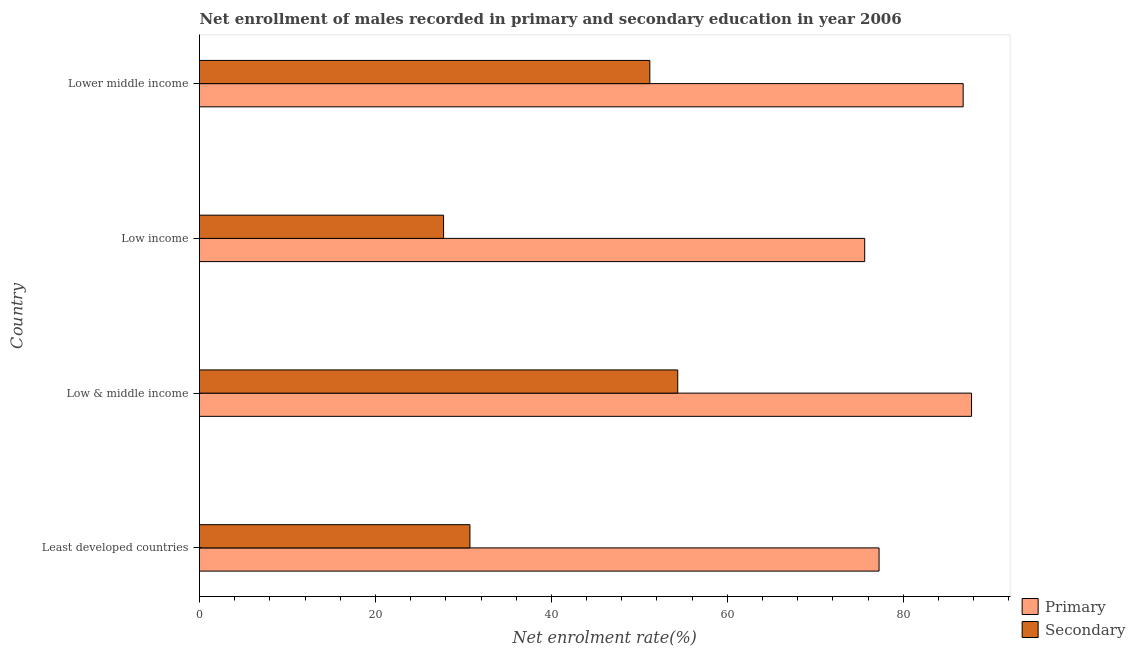How many different coloured bars are there?
Give a very brief answer. 2. How many groups of bars are there?
Offer a terse response. 4. Are the number of bars per tick equal to the number of legend labels?
Keep it short and to the point. Yes. What is the label of the 2nd group of bars from the top?
Offer a very short reply. Low income. What is the enrollment rate in primary education in Low income?
Your response must be concise. 75.61. Across all countries, what is the maximum enrollment rate in secondary education?
Give a very brief answer. 54.36. Across all countries, what is the minimum enrollment rate in primary education?
Your answer should be compact. 75.61. In which country was the enrollment rate in secondary education minimum?
Offer a terse response. Low income. What is the total enrollment rate in secondary education in the graph?
Make the answer very short. 164.04. What is the difference between the enrollment rate in primary education in Least developed countries and that in Lower middle income?
Your answer should be compact. -9.56. What is the difference between the enrollment rate in primary education in Low & middle income and the enrollment rate in secondary education in Lower middle income?
Your answer should be very brief. 36.57. What is the average enrollment rate in secondary education per country?
Offer a very short reply. 41.01. What is the difference between the enrollment rate in primary education and enrollment rate in secondary education in Lower middle income?
Provide a short and direct response. 35.62. In how many countries, is the enrollment rate in secondary education greater than 56 %?
Give a very brief answer. 0. What is the ratio of the enrollment rate in secondary education in Low & middle income to that in Lower middle income?
Your response must be concise. 1.06. What is the difference between the highest and the lowest enrollment rate in primary education?
Offer a very short reply. 12.14. In how many countries, is the enrollment rate in secondary education greater than the average enrollment rate in secondary education taken over all countries?
Your answer should be compact. 2. Is the sum of the enrollment rate in primary education in Low & middle income and Low income greater than the maximum enrollment rate in secondary education across all countries?
Keep it short and to the point. Yes. What does the 1st bar from the top in Least developed countries represents?
Your response must be concise. Secondary. What does the 2nd bar from the bottom in Lower middle income represents?
Make the answer very short. Secondary. What is the difference between two consecutive major ticks on the X-axis?
Provide a short and direct response. 20. Are the values on the major ticks of X-axis written in scientific E-notation?
Offer a terse response. No. Does the graph contain any zero values?
Keep it short and to the point. No. Does the graph contain grids?
Ensure brevity in your answer.  No. Where does the legend appear in the graph?
Your response must be concise. Bottom right. How many legend labels are there?
Your answer should be compact. 2. What is the title of the graph?
Keep it short and to the point. Net enrollment of males recorded in primary and secondary education in year 2006. What is the label or title of the X-axis?
Keep it short and to the point. Net enrolment rate(%). What is the Net enrolment rate(%) in Primary in Least developed countries?
Ensure brevity in your answer.  77.25. What is the Net enrolment rate(%) of Secondary in Least developed countries?
Offer a very short reply. 30.74. What is the Net enrolment rate(%) of Primary in Low & middle income?
Provide a short and direct response. 87.76. What is the Net enrolment rate(%) of Secondary in Low & middle income?
Provide a succinct answer. 54.36. What is the Net enrolment rate(%) of Primary in Low income?
Your answer should be very brief. 75.61. What is the Net enrolment rate(%) in Secondary in Low income?
Ensure brevity in your answer.  27.75. What is the Net enrolment rate(%) in Primary in Lower middle income?
Provide a short and direct response. 86.81. What is the Net enrolment rate(%) of Secondary in Lower middle income?
Give a very brief answer. 51.19. Across all countries, what is the maximum Net enrolment rate(%) of Primary?
Your answer should be very brief. 87.76. Across all countries, what is the maximum Net enrolment rate(%) of Secondary?
Give a very brief answer. 54.36. Across all countries, what is the minimum Net enrolment rate(%) in Primary?
Give a very brief answer. 75.61. Across all countries, what is the minimum Net enrolment rate(%) in Secondary?
Ensure brevity in your answer.  27.75. What is the total Net enrolment rate(%) of Primary in the graph?
Keep it short and to the point. 327.43. What is the total Net enrolment rate(%) in Secondary in the graph?
Ensure brevity in your answer.  164.04. What is the difference between the Net enrolment rate(%) in Primary in Least developed countries and that in Low & middle income?
Keep it short and to the point. -10.51. What is the difference between the Net enrolment rate(%) of Secondary in Least developed countries and that in Low & middle income?
Keep it short and to the point. -23.62. What is the difference between the Net enrolment rate(%) of Primary in Least developed countries and that in Low income?
Give a very brief answer. 1.63. What is the difference between the Net enrolment rate(%) of Secondary in Least developed countries and that in Low income?
Keep it short and to the point. 3. What is the difference between the Net enrolment rate(%) in Primary in Least developed countries and that in Lower middle income?
Provide a short and direct response. -9.56. What is the difference between the Net enrolment rate(%) of Secondary in Least developed countries and that in Lower middle income?
Ensure brevity in your answer.  -20.45. What is the difference between the Net enrolment rate(%) of Primary in Low & middle income and that in Low income?
Give a very brief answer. 12.14. What is the difference between the Net enrolment rate(%) in Secondary in Low & middle income and that in Low income?
Offer a very short reply. 26.62. What is the difference between the Net enrolment rate(%) in Primary in Low & middle income and that in Lower middle income?
Your answer should be very brief. 0.95. What is the difference between the Net enrolment rate(%) in Secondary in Low & middle income and that in Lower middle income?
Ensure brevity in your answer.  3.17. What is the difference between the Net enrolment rate(%) of Primary in Low income and that in Lower middle income?
Provide a succinct answer. -11.19. What is the difference between the Net enrolment rate(%) in Secondary in Low income and that in Lower middle income?
Your answer should be compact. -23.44. What is the difference between the Net enrolment rate(%) of Primary in Least developed countries and the Net enrolment rate(%) of Secondary in Low & middle income?
Offer a terse response. 22.88. What is the difference between the Net enrolment rate(%) in Primary in Least developed countries and the Net enrolment rate(%) in Secondary in Low income?
Provide a succinct answer. 49.5. What is the difference between the Net enrolment rate(%) in Primary in Least developed countries and the Net enrolment rate(%) in Secondary in Lower middle income?
Your response must be concise. 26.06. What is the difference between the Net enrolment rate(%) of Primary in Low & middle income and the Net enrolment rate(%) of Secondary in Low income?
Give a very brief answer. 60.01. What is the difference between the Net enrolment rate(%) in Primary in Low & middle income and the Net enrolment rate(%) in Secondary in Lower middle income?
Ensure brevity in your answer.  36.57. What is the difference between the Net enrolment rate(%) in Primary in Low income and the Net enrolment rate(%) in Secondary in Lower middle income?
Your answer should be compact. 24.42. What is the average Net enrolment rate(%) of Primary per country?
Your answer should be very brief. 81.86. What is the average Net enrolment rate(%) of Secondary per country?
Give a very brief answer. 41.01. What is the difference between the Net enrolment rate(%) in Primary and Net enrolment rate(%) in Secondary in Least developed countries?
Keep it short and to the point. 46.51. What is the difference between the Net enrolment rate(%) of Primary and Net enrolment rate(%) of Secondary in Low & middle income?
Provide a succinct answer. 33.39. What is the difference between the Net enrolment rate(%) in Primary and Net enrolment rate(%) in Secondary in Low income?
Your answer should be compact. 47.87. What is the difference between the Net enrolment rate(%) in Primary and Net enrolment rate(%) in Secondary in Lower middle income?
Provide a succinct answer. 35.62. What is the ratio of the Net enrolment rate(%) of Primary in Least developed countries to that in Low & middle income?
Offer a very short reply. 0.88. What is the ratio of the Net enrolment rate(%) of Secondary in Least developed countries to that in Low & middle income?
Your answer should be very brief. 0.57. What is the ratio of the Net enrolment rate(%) in Primary in Least developed countries to that in Low income?
Provide a short and direct response. 1.02. What is the ratio of the Net enrolment rate(%) in Secondary in Least developed countries to that in Low income?
Your answer should be compact. 1.11. What is the ratio of the Net enrolment rate(%) in Primary in Least developed countries to that in Lower middle income?
Keep it short and to the point. 0.89. What is the ratio of the Net enrolment rate(%) in Secondary in Least developed countries to that in Lower middle income?
Provide a short and direct response. 0.6. What is the ratio of the Net enrolment rate(%) of Primary in Low & middle income to that in Low income?
Your answer should be compact. 1.16. What is the ratio of the Net enrolment rate(%) of Secondary in Low & middle income to that in Low income?
Offer a terse response. 1.96. What is the ratio of the Net enrolment rate(%) of Primary in Low & middle income to that in Lower middle income?
Provide a succinct answer. 1.01. What is the ratio of the Net enrolment rate(%) of Secondary in Low & middle income to that in Lower middle income?
Offer a terse response. 1.06. What is the ratio of the Net enrolment rate(%) of Primary in Low income to that in Lower middle income?
Keep it short and to the point. 0.87. What is the ratio of the Net enrolment rate(%) in Secondary in Low income to that in Lower middle income?
Ensure brevity in your answer.  0.54. What is the difference between the highest and the second highest Net enrolment rate(%) in Primary?
Your response must be concise. 0.95. What is the difference between the highest and the second highest Net enrolment rate(%) in Secondary?
Offer a very short reply. 3.17. What is the difference between the highest and the lowest Net enrolment rate(%) in Primary?
Give a very brief answer. 12.14. What is the difference between the highest and the lowest Net enrolment rate(%) of Secondary?
Ensure brevity in your answer.  26.62. 